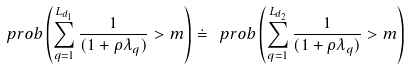<formula> <loc_0><loc_0><loc_500><loc_500>\ p r o b \left ( \sum _ { q = 1 } ^ { L _ { d _ { 1 } } } \frac { 1 } { ( 1 + \rho \lambda _ { q } ) } > m \right ) \doteq \ p r o b \left ( \sum _ { q = 1 } ^ { L _ { d _ { 2 } } } \frac { 1 } { ( 1 + \rho \lambda _ { q } ) } > m \right )</formula> 